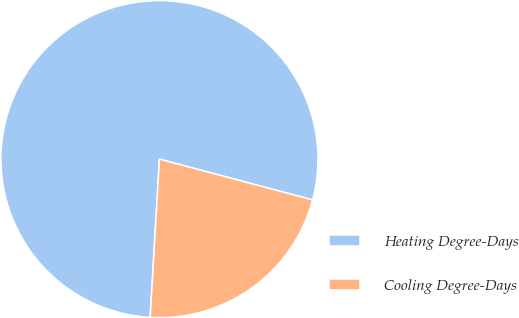<chart> <loc_0><loc_0><loc_500><loc_500><pie_chart><fcel>Heating Degree-Days<fcel>Cooling Degree-Days<nl><fcel>78.21%<fcel>21.79%<nl></chart> 